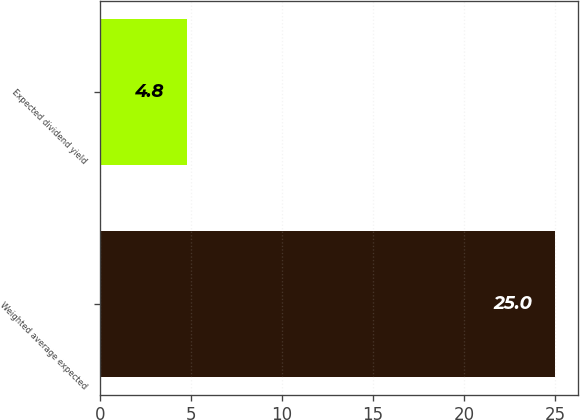Convert chart. <chart><loc_0><loc_0><loc_500><loc_500><bar_chart><fcel>Weighted average expected<fcel>Expected dividend yield<nl><fcel>25<fcel>4.8<nl></chart> 